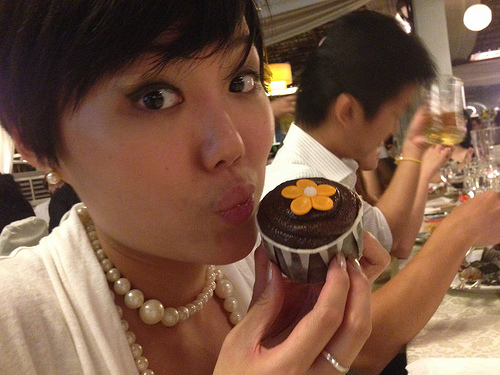Who holds the dessert in the middle of the image? A person holds the dessert in the middle of the image. 